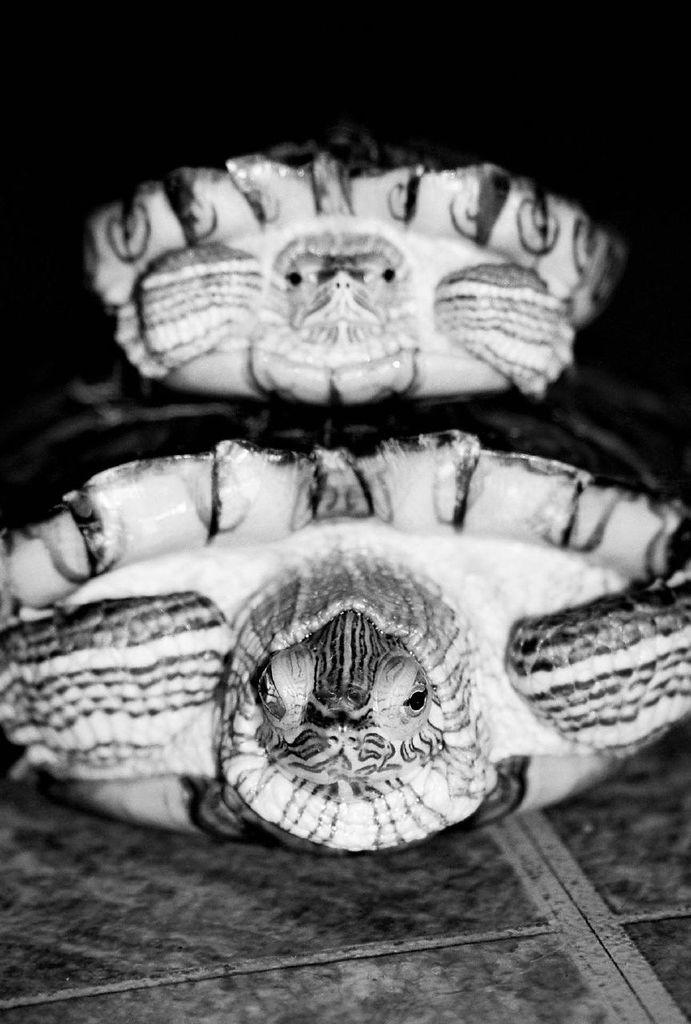What type of animals can be seen on the ground in the image? The facts provided do not specify the type of animals, so we cannot definitively answer this question. What can be observed about the background of the image? The background of the image is dark. How many beetles can be seen in the image? There is no mention of beetles in the provided facts, so we cannot definitively answer this question. What is the cause of the dark background in the image? The provided facts do not offer any information about the cause of the dark background, so we cannot definitively answer this question. 